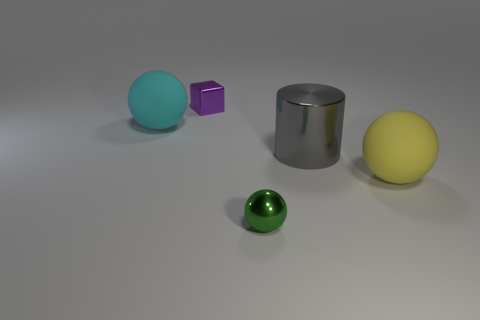Is the number of large gray rubber blocks less than the number of gray shiny cylinders?
Give a very brief answer. Yes. There is a tiny shiny thing behind the large rubber sphere left of the large thing that is in front of the big cylinder; what color is it?
Your answer should be very brief. Purple. Are the tiny purple object and the large cyan thing made of the same material?
Your response must be concise. No. How many metallic cylinders are behind the large yellow thing?
Ensure brevity in your answer.  1. What size is the shiny object that is the same shape as the large yellow matte object?
Make the answer very short. Small. What number of gray objects are large matte things or tiny spheres?
Make the answer very short. 0. There is a big rubber sphere in front of the cyan matte object; how many small objects are in front of it?
Ensure brevity in your answer.  1. How many other objects are the same shape as the cyan thing?
Give a very brief answer. 2. What number of large balls have the same color as the big cylinder?
Give a very brief answer. 0. There is a cylinder that is the same material as the tiny purple cube; what color is it?
Offer a very short reply. Gray. 